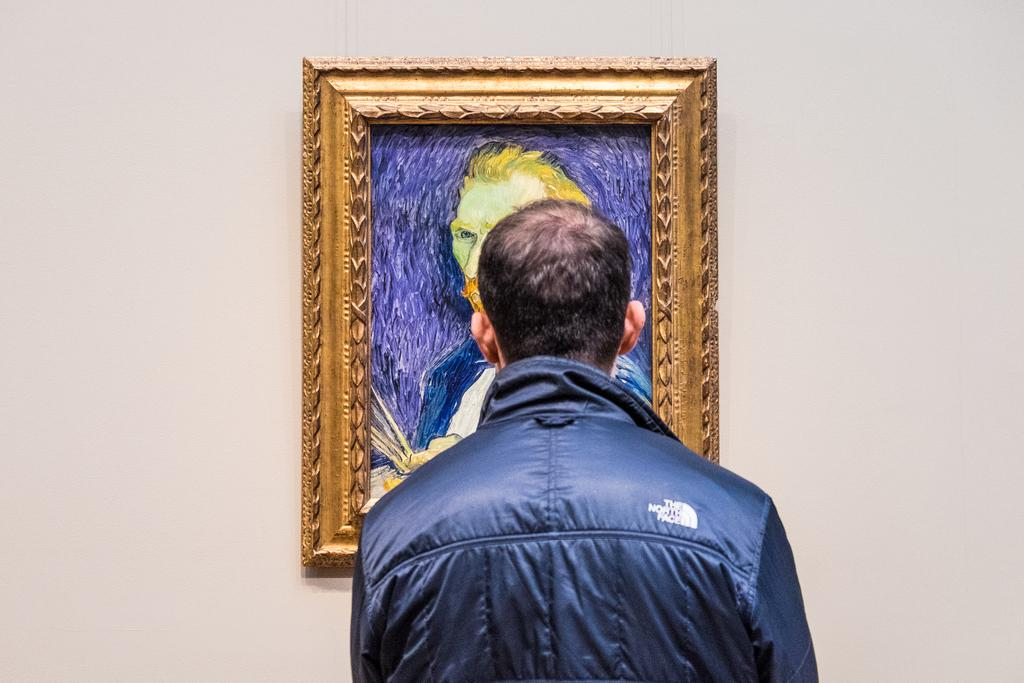Who is present in the image? There is a person in the image. What is the person wearing? The person is wearing a jacket. What is the person doing in relation to the place they are standing over? The person is standing over a place, but the specific action is not mentioned. What can be seen on the wall in front of the person? There is a painting on the wall in front of the person. What is the person's focus in the image? The person is watching the painting. What songs are being sung by the person in the image? There is no mention of singing or songs in the image. The person is focused on watching the painting. 